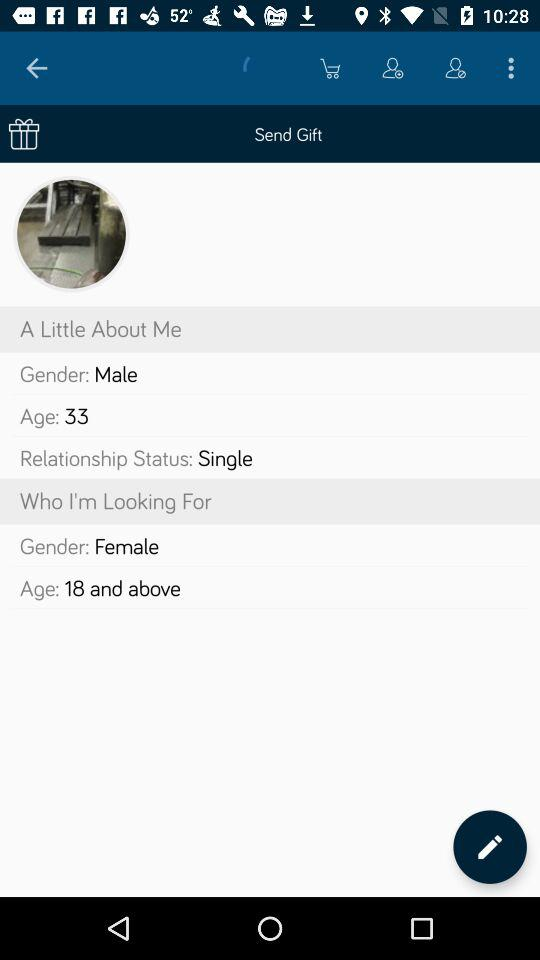What is the gender to whom I'm looking for? The gender is female. 